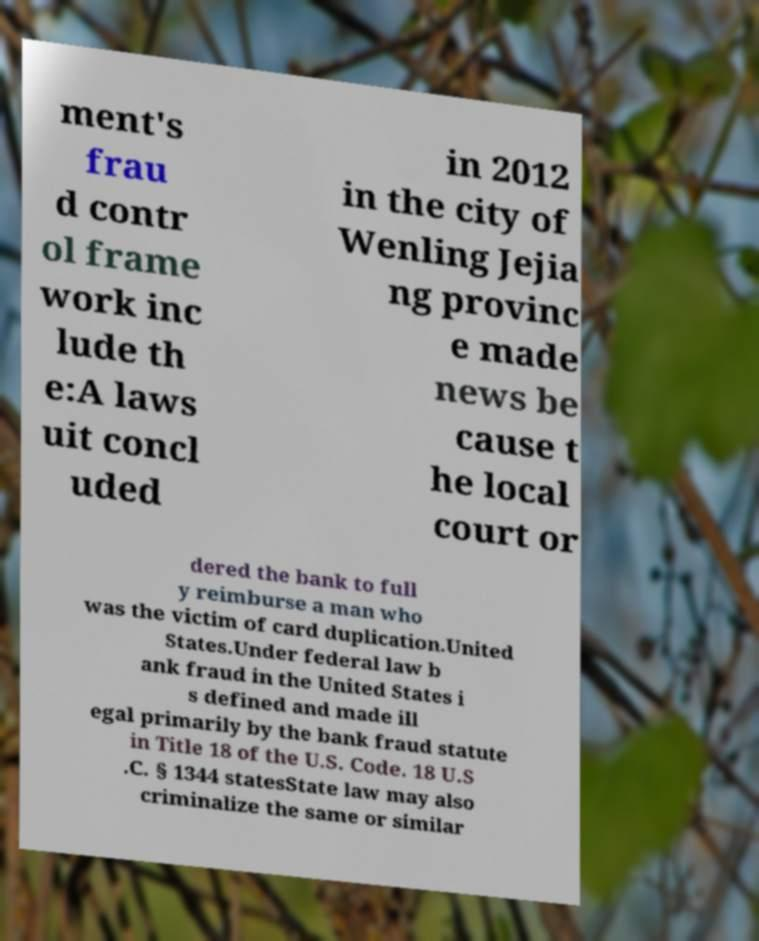Please read and relay the text visible in this image. What does it say? ment's frau d contr ol frame work inc lude th e:A laws uit concl uded in 2012 in the city of Wenling Jejia ng provinc e made news be cause t he local court or dered the bank to full y reimburse a man who was the victim of card duplication.United States.Under federal law b ank fraud in the United States i s defined and made ill egal primarily by the bank fraud statute in Title 18 of the U.S. Code. 18 U.S .C. § 1344 statesState law may also criminalize the same or similar 